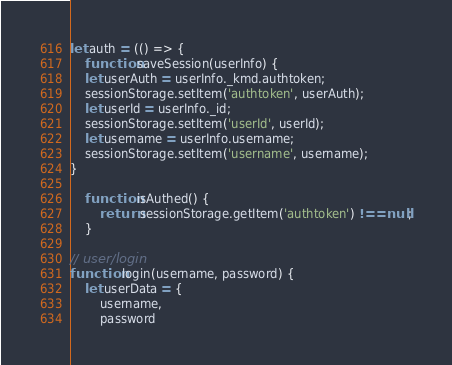<code> <loc_0><loc_0><loc_500><loc_500><_JavaScript_>let auth = (() => {
    function saveSession(userInfo) {
    let userAuth = userInfo._kmd.authtoken;
    sessionStorage.setItem('authtoken', userAuth);
    let userId = userInfo._id;
    sessionStorage.setItem('userId', userId);
    let username = userInfo.username;
    sessionStorage.setItem('username', username);
}

    function isAuthed() {
        return sessionStorage.getItem('authtoken') !== null;
    }

// user/login
function login(username, password) {
    let userData = {
        username,
        password</code> 